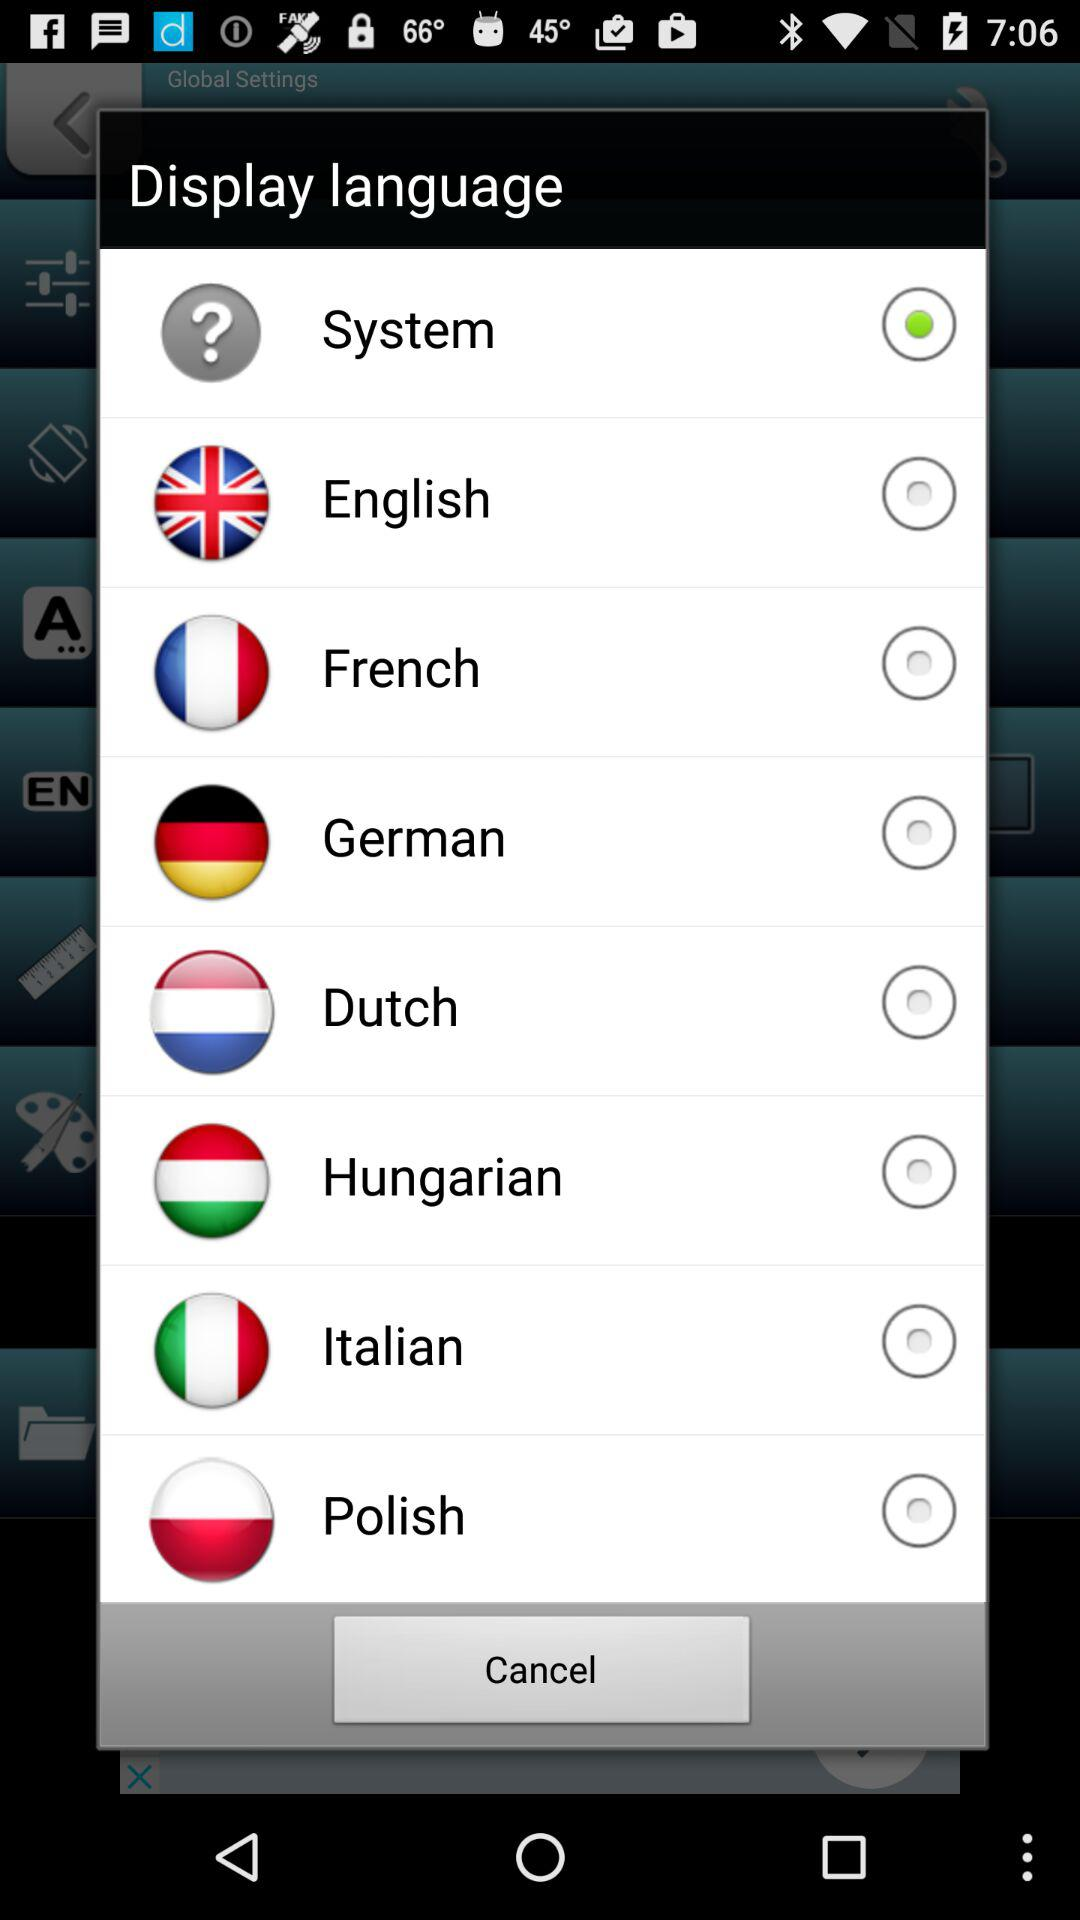What is the selected option? The selected option is "System". 